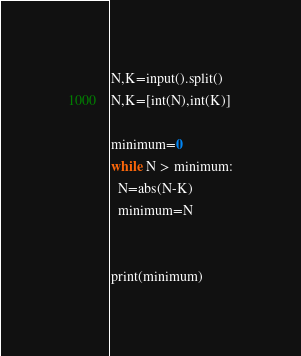<code> <loc_0><loc_0><loc_500><loc_500><_Python_>N,K=input().split()
N,K=[int(N),int(K)]

minimum=0
while N > minimum:
  N=abs(N-K)
  minimum=N
  
  
print(minimum)</code> 